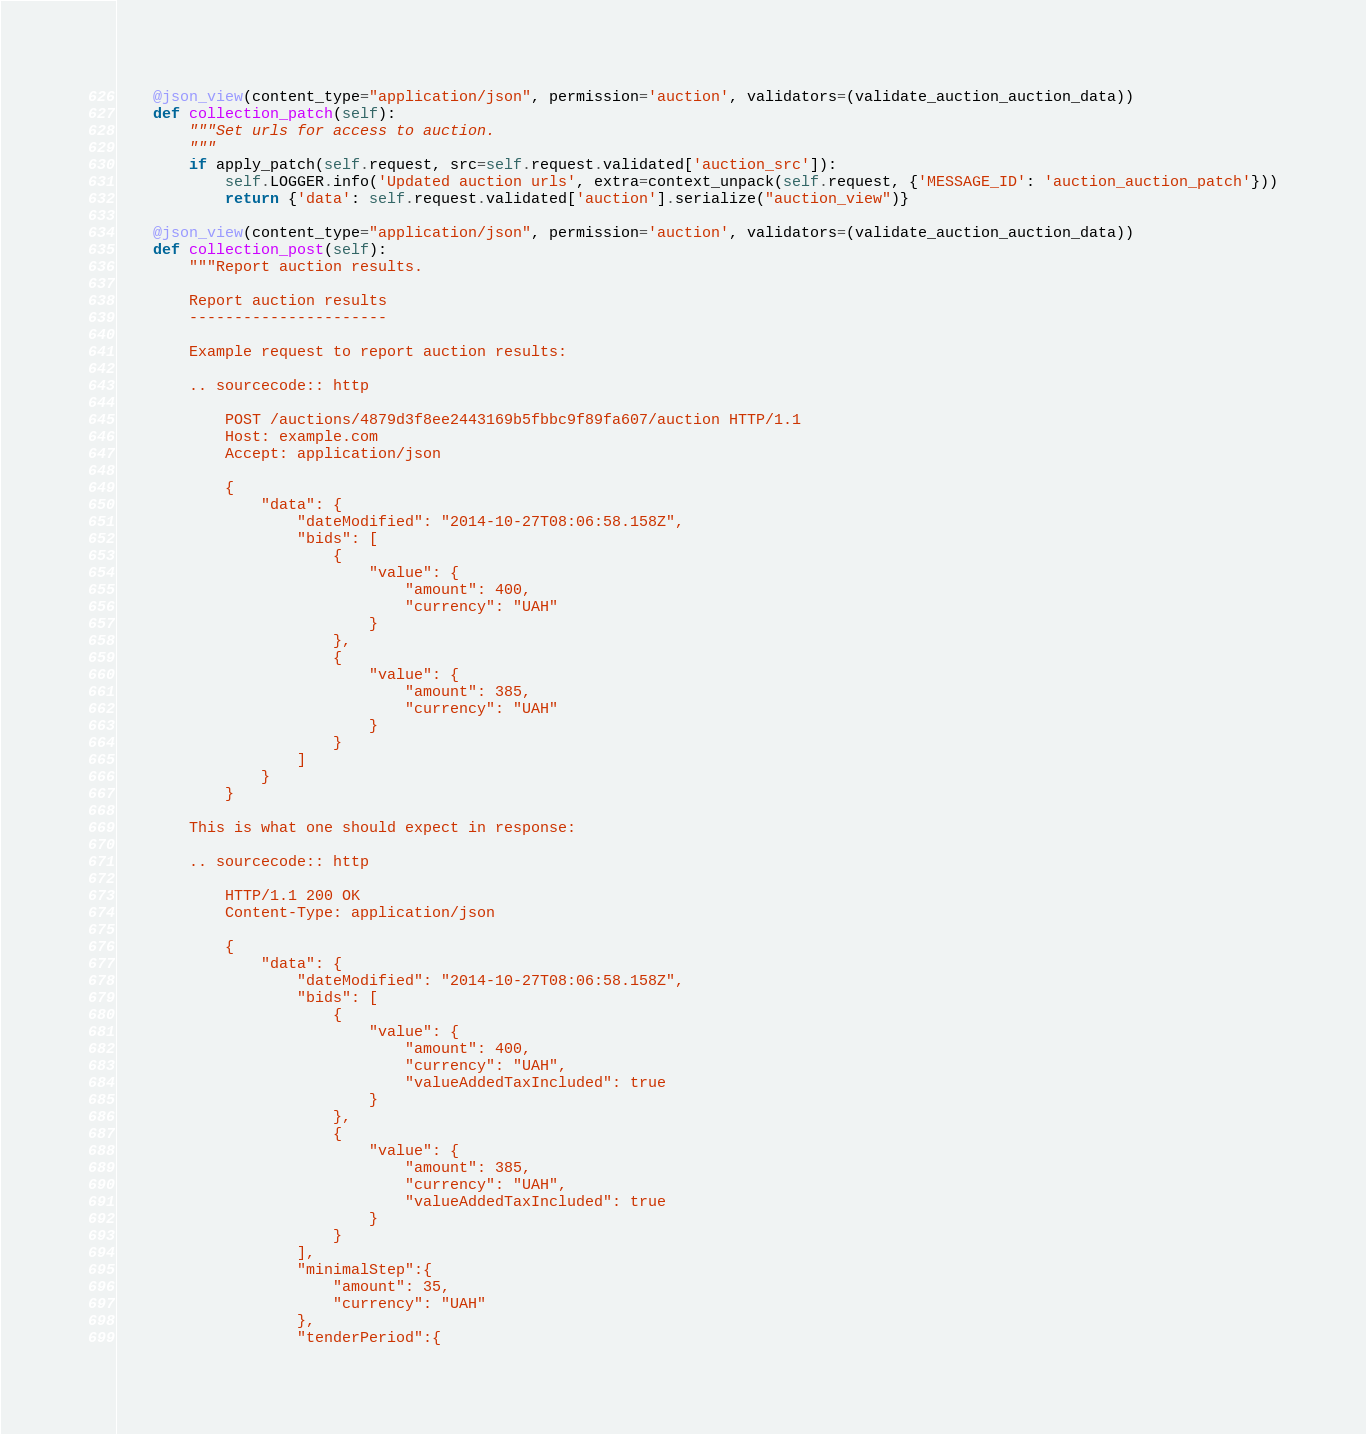<code> <loc_0><loc_0><loc_500><loc_500><_Python_>    @json_view(content_type="application/json", permission='auction', validators=(validate_auction_auction_data))
    def collection_patch(self):
        """Set urls for access to auction.
        """
        if apply_patch(self.request, src=self.request.validated['auction_src']):
            self.LOGGER.info('Updated auction urls', extra=context_unpack(self.request, {'MESSAGE_ID': 'auction_auction_patch'}))
            return {'data': self.request.validated['auction'].serialize("auction_view")}

    @json_view(content_type="application/json", permission='auction', validators=(validate_auction_auction_data))
    def collection_post(self):
        """Report auction results.

        Report auction results
        ----------------------

        Example request to report auction results:

        .. sourcecode:: http

            POST /auctions/4879d3f8ee2443169b5fbbc9f89fa607/auction HTTP/1.1
            Host: example.com
            Accept: application/json

            {
                "data": {
                    "dateModified": "2014-10-27T08:06:58.158Z",
                    "bids": [
                        {
                            "value": {
                                "amount": 400,
                                "currency": "UAH"
                            }
                        },
                        {
                            "value": {
                                "amount": 385,
                                "currency": "UAH"
                            }
                        }
                    ]
                }
            }

        This is what one should expect in response:

        .. sourcecode:: http

            HTTP/1.1 200 OK
            Content-Type: application/json

            {
                "data": {
                    "dateModified": "2014-10-27T08:06:58.158Z",
                    "bids": [
                        {
                            "value": {
                                "amount": 400,
                                "currency": "UAH",
                                "valueAddedTaxIncluded": true
                            }
                        },
                        {
                            "value": {
                                "amount": 385,
                                "currency": "UAH",
                                "valueAddedTaxIncluded": true
                            }
                        }
                    ],
                    "minimalStep":{
                        "amount": 35,
                        "currency": "UAH"
                    },
                    "tenderPeriod":{</code> 